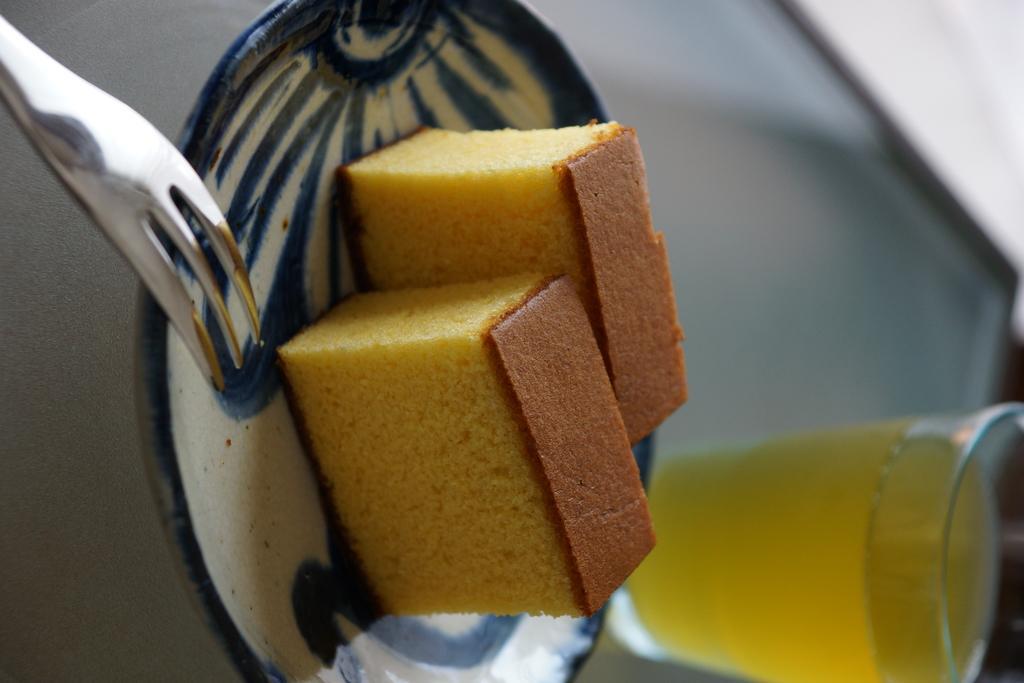Describe this image in one or two sentences. In this picture I can see two cake slices on the plate, there is a fork and there is a glass with a liquid in it, on an object, and there is blur background. 